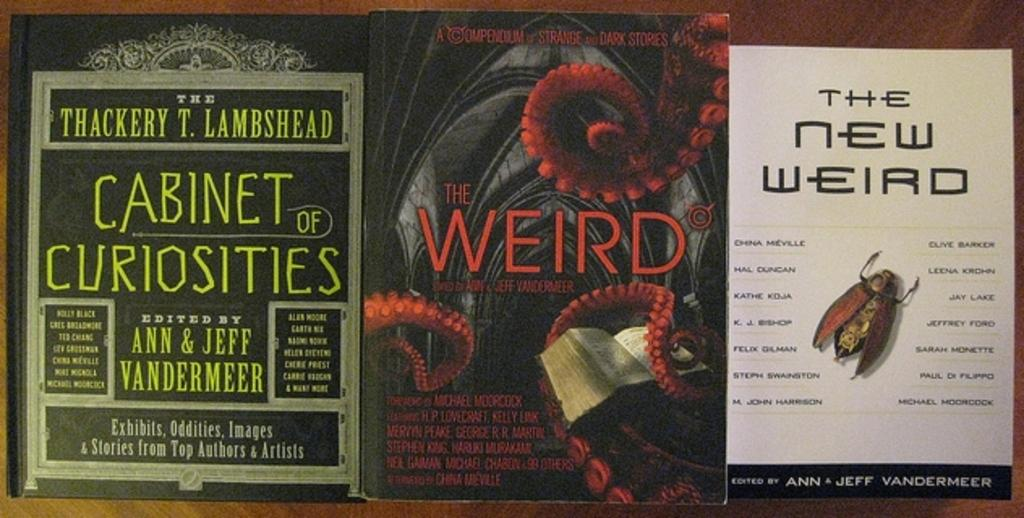What is the main object in the image? There is a table in the image. What items are placed on the table? There are three books on the table. What can be found on the books? There is text written on the books, and there are pictures on them. What type of engine is depicted in the image? There is no engine present in the image; it features a table with three books on it. How many books are on the fifth shelf in the image? There is no mention of shelves or a fifth shelf in the image; it only shows a table with three books on it. 